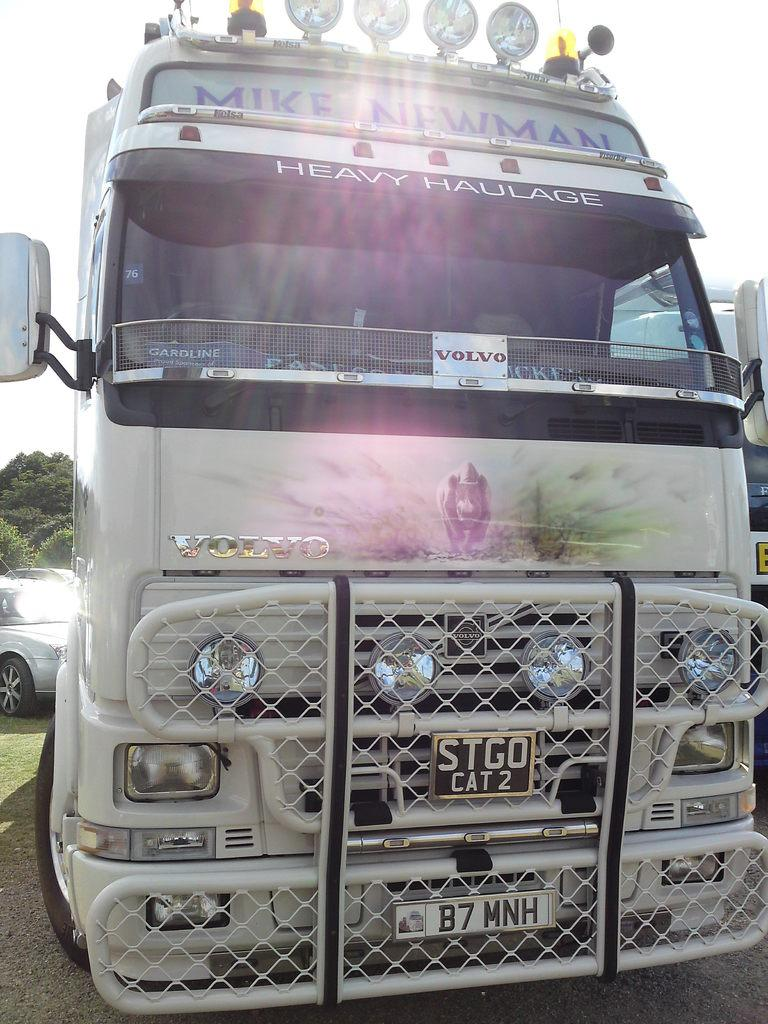<image>
Give a short and clear explanation of the subsequent image. A Volvo brandtour bus for Mike Newman with tag reading B7 MNH. 